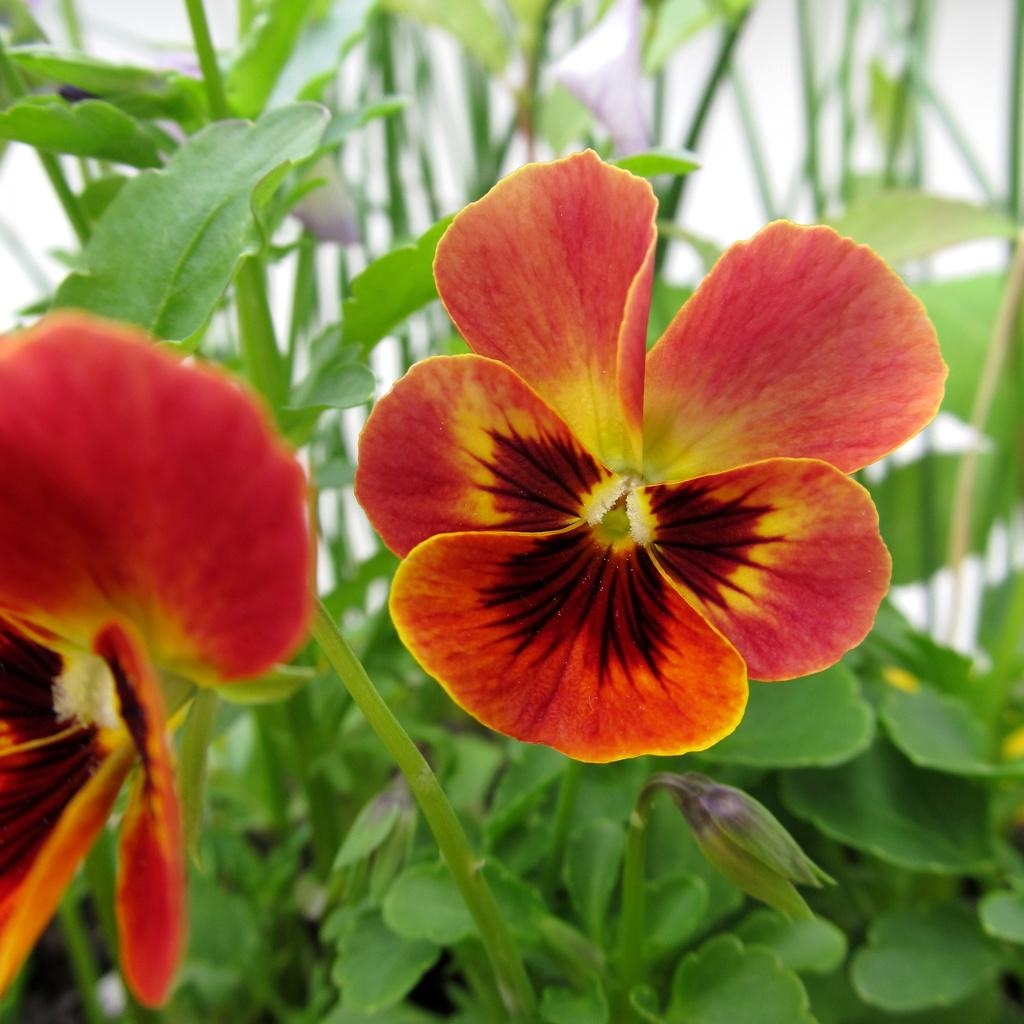What type of living organisms can be seen in the image? Plants, leaves, and flowers are visible in the image. What specific parts of the plants are shown in the image? Leaves and flowers are shown in the image. Can you describe the flowers in the image? The flowers have red and brown colors in the middle. What type of test is being conducted on the secretary in the image? There is no secretary or test present in the image; it features plants, leaves, and flowers. How does the grandfather interact with the flowers in the image? There is no grandfather present in the image; it features plants, leaves, and flowers. 